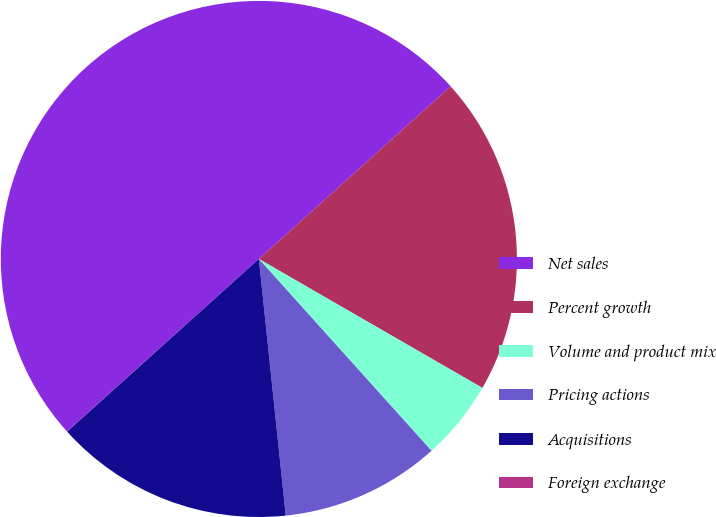<chart> <loc_0><loc_0><loc_500><loc_500><pie_chart><fcel>Net sales<fcel>Percent growth<fcel>Volume and product mix<fcel>Pricing actions<fcel>Acquisitions<fcel>Foreign exchange<nl><fcel>49.99%<fcel>20.0%<fcel>5.01%<fcel>10.0%<fcel>15.0%<fcel>0.01%<nl></chart> 